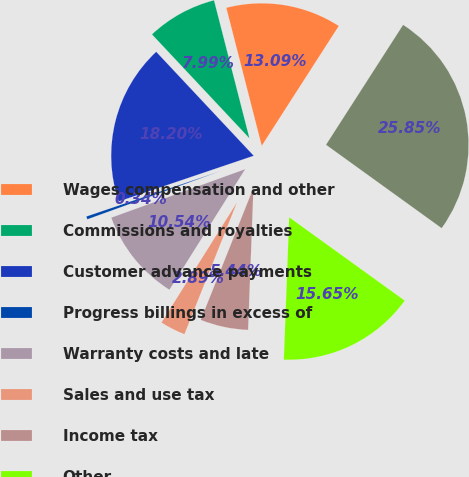Convert chart. <chart><loc_0><loc_0><loc_500><loc_500><pie_chart><fcel>Wages compensation and other<fcel>Commissions and royalties<fcel>Customer advance payments<fcel>Progress billings in excess of<fcel>Warranty costs and late<fcel>Sales and use tax<fcel>Income tax<fcel>Other<fcel>Accrued liabilities<nl><fcel>13.09%<fcel>7.99%<fcel>18.2%<fcel>0.34%<fcel>10.54%<fcel>2.89%<fcel>5.44%<fcel>15.65%<fcel>25.85%<nl></chart> 